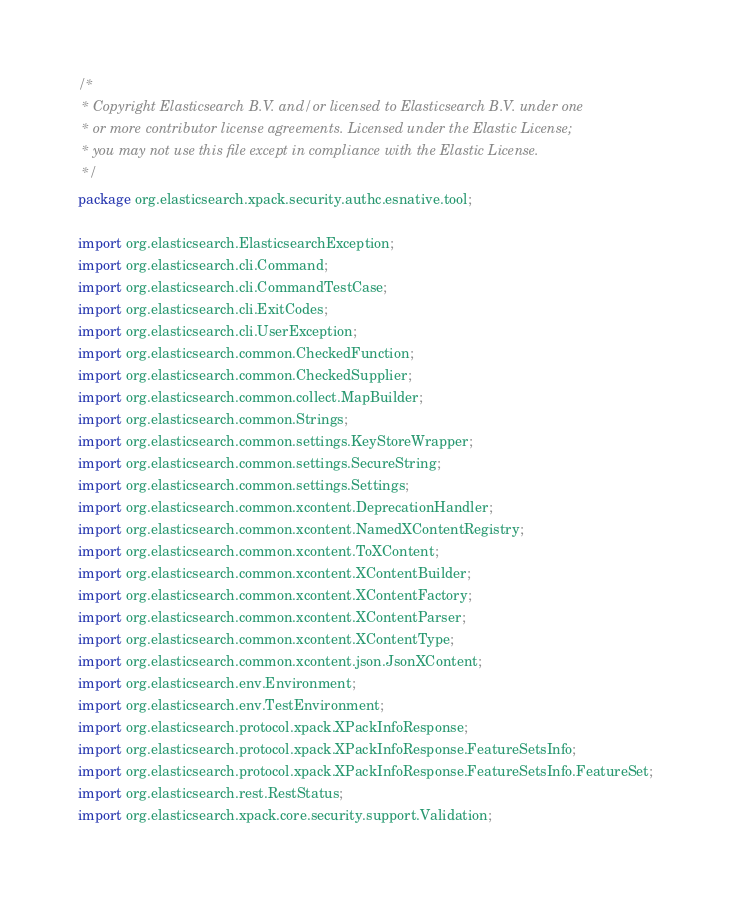<code> <loc_0><loc_0><loc_500><loc_500><_Java_>/*
 * Copyright Elasticsearch B.V. and/or licensed to Elasticsearch B.V. under one
 * or more contributor license agreements. Licensed under the Elastic License;
 * you may not use this file except in compliance with the Elastic License.
 */
package org.elasticsearch.xpack.security.authc.esnative.tool;

import org.elasticsearch.ElasticsearchException;
import org.elasticsearch.cli.Command;
import org.elasticsearch.cli.CommandTestCase;
import org.elasticsearch.cli.ExitCodes;
import org.elasticsearch.cli.UserException;
import org.elasticsearch.common.CheckedFunction;
import org.elasticsearch.common.CheckedSupplier;
import org.elasticsearch.common.collect.MapBuilder;
import org.elasticsearch.common.Strings;
import org.elasticsearch.common.settings.KeyStoreWrapper;
import org.elasticsearch.common.settings.SecureString;
import org.elasticsearch.common.settings.Settings;
import org.elasticsearch.common.xcontent.DeprecationHandler;
import org.elasticsearch.common.xcontent.NamedXContentRegistry;
import org.elasticsearch.common.xcontent.ToXContent;
import org.elasticsearch.common.xcontent.XContentBuilder;
import org.elasticsearch.common.xcontent.XContentFactory;
import org.elasticsearch.common.xcontent.XContentParser;
import org.elasticsearch.common.xcontent.XContentType;
import org.elasticsearch.common.xcontent.json.JsonXContent;
import org.elasticsearch.env.Environment;
import org.elasticsearch.env.TestEnvironment;
import org.elasticsearch.protocol.xpack.XPackInfoResponse;
import org.elasticsearch.protocol.xpack.XPackInfoResponse.FeatureSetsInfo;
import org.elasticsearch.protocol.xpack.XPackInfoResponse.FeatureSetsInfo.FeatureSet;
import org.elasticsearch.rest.RestStatus;
import org.elasticsearch.xpack.core.security.support.Validation;</code> 